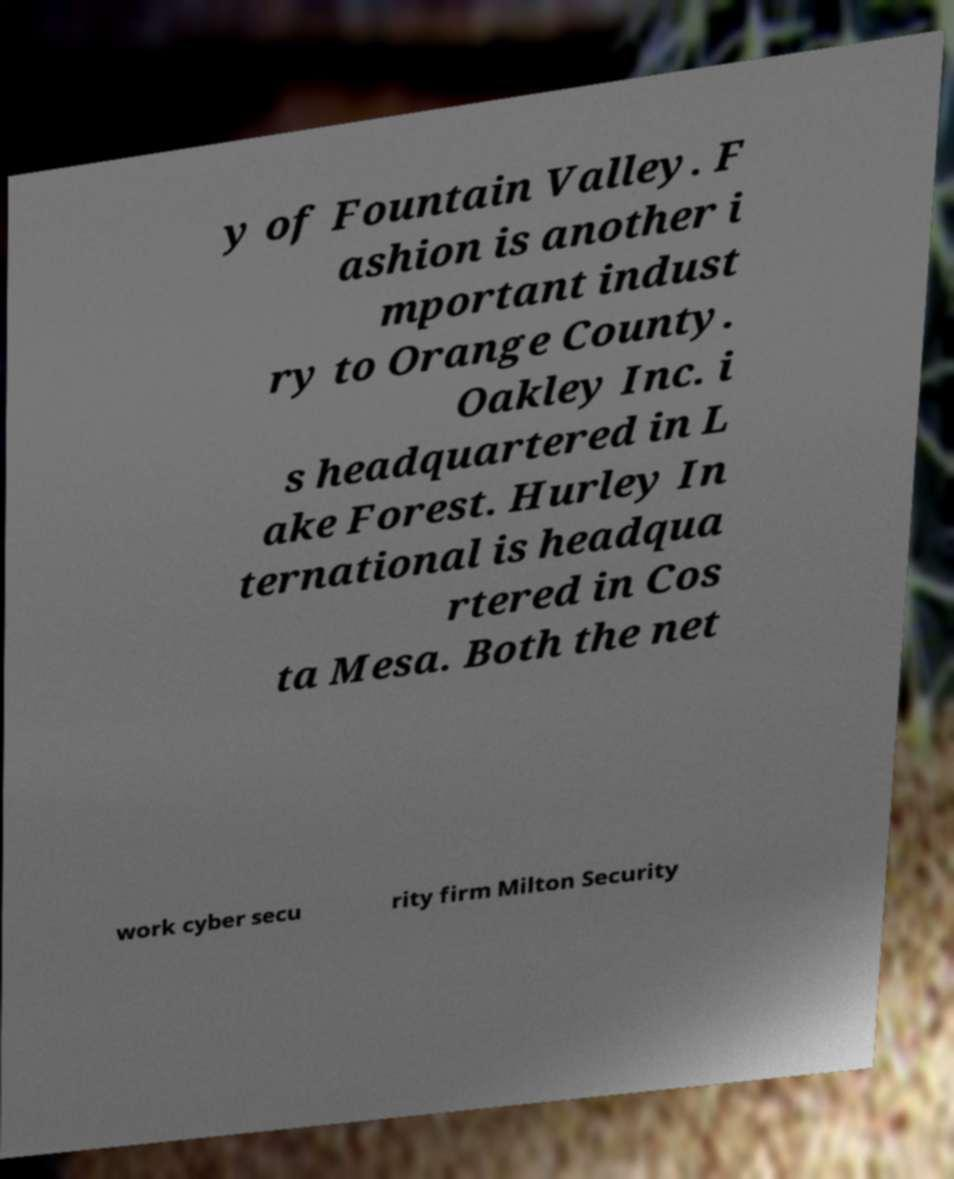There's text embedded in this image that I need extracted. Can you transcribe it verbatim? y of Fountain Valley. F ashion is another i mportant indust ry to Orange County. Oakley Inc. i s headquartered in L ake Forest. Hurley In ternational is headqua rtered in Cos ta Mesa. Both the net work cyber secu rity firm Milton Security 